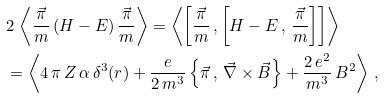<formula> <loc_0><loc_0><loc_500><loc_500>& 2 \, \left \langle \frac { \vec { \pi } } { m } \, ( H - E ) \, \frac { \vec { \pi } } { m } \right \rangle = \left \langle \left [ \frac { \vec { \pi } } { m } \, , \left [ H - E \, , \, \frac { \vec { \pi } } { m } \right ] \right ] \right \rangle \\ & = \left \langle 4 \, \pi \, Z \, \alpha \, \delta ^ { 3 } ( r ) + \frac { e } { 2 \, m ^ { 3 } } \left \{ \vec { \pi } \, , \, \vec { \nabla } \times \vec { B } \right \} + \frac { 2 \, e ^ { 2 } } { m ^ { 3 } } \, B ^ { 2 } \right \rangle \, ,</formula> 